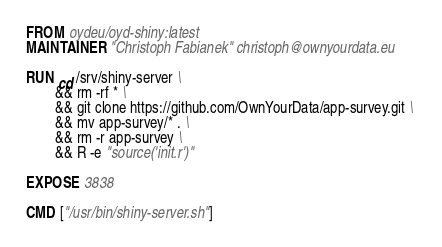Convert code to text. <code><loc_0><loc_0><loc_500><loc_500><_Dockerfile_>FROM oydeu/oyd-shiny:latest
MAINTAINER "Christoph Fabianek" christoph@ownyourdata.eu

RUN cd /srv/shiny-server \
        && rm -rf * \
        && git clone https://github.com/OwnYourData/app-survey.git \ 
        && mv app-survey/* . \
        && rm -r app-survey \
        && R -e "source('init.r')"

EXPOSE 3838

CMD ["/usr/bin/shiny-server.sh"]
</code> 